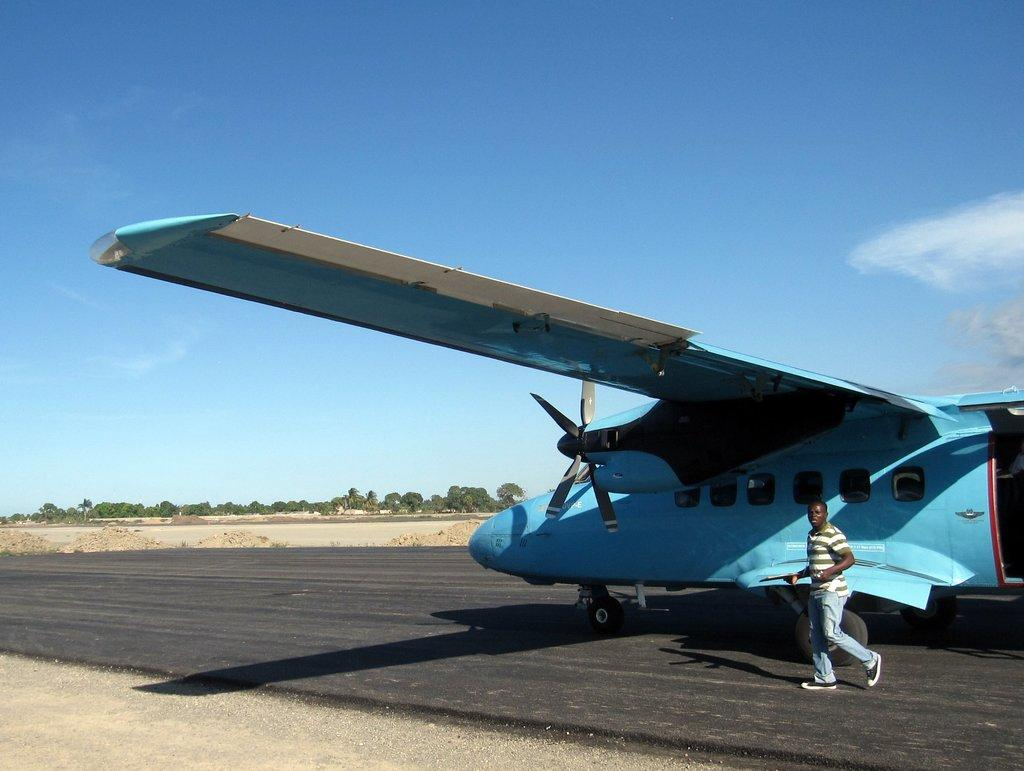What is the main subject of the picture? The main subject of the picture is an airplane. Can you describe the man beside the airplane? There is a man standing beside the airplane, but no specific details about his appearance or actions are provided. What can be seen in the background of the picture? There are trees and clouds visible in the background of the picture. What type of metal is the parcel made of in the image? There is no parcel present in the image, so it is not possible to determine what type of metal it might be made of. 